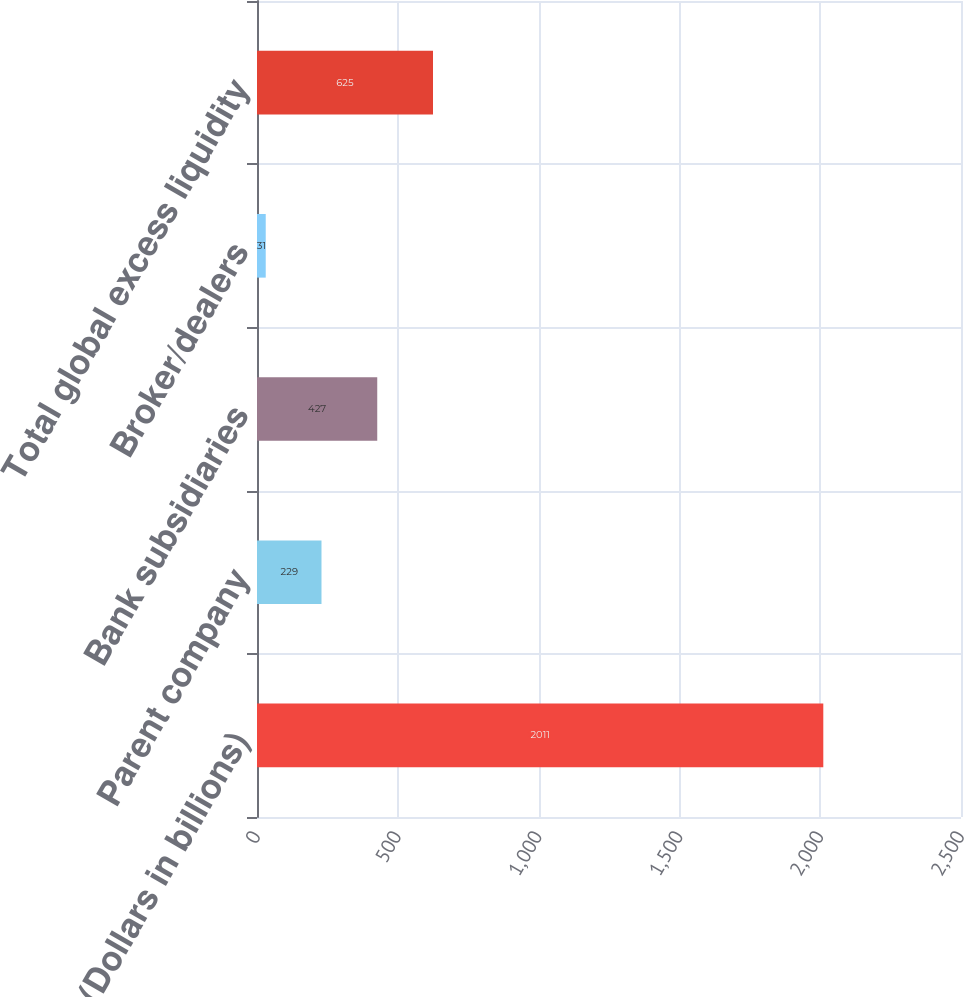Convert chart to OTSL. <chart><loc_0><loc_0><loc_500><loc_500><bar_chart><fcel>(Dollars in billions)<fcel>Parent company<fcel>Bank subsidiaries<fcel>Broker/dealers<fcel>Total global excess liquidity<nl><fcel>2011<fcel>229<fcel>427<fcel>31<fcel>625<nl></chart> 